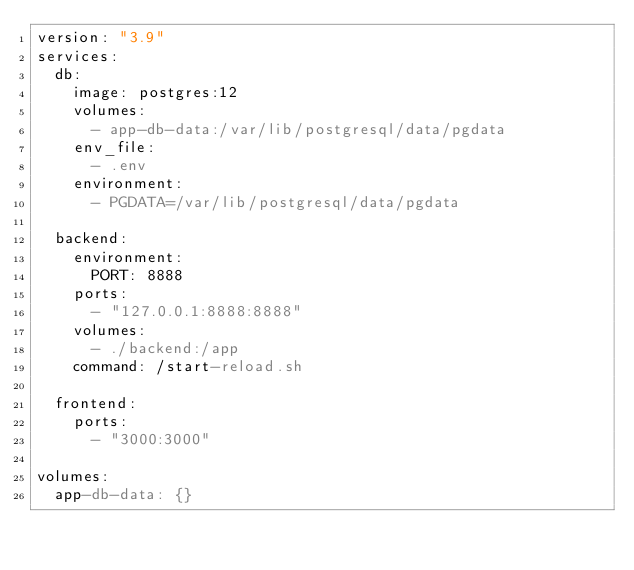Convert code to text. <code><loc_0><loc_0><loc_500><loc_500><_YAML_>version: "3.9"
services:
  db:
    image: postgres:12
    volumes:
      - app-db-data:/var/lib/postgresql/data/pgdata
    env_file:
      - .env
    environment:
      - PGDATA=/var/lib/postgresql/data/pgdata

  backend:
    environment:
      PORT: 8888
    ports:
      - "127.0.0.1:8888:8888"
    volumes:
      - ./backend:/app
    command: /start-reload.sh

  frontend:
    ports:
      - "3000:3000"

volumes:
  app-db-data: {}
</code> 